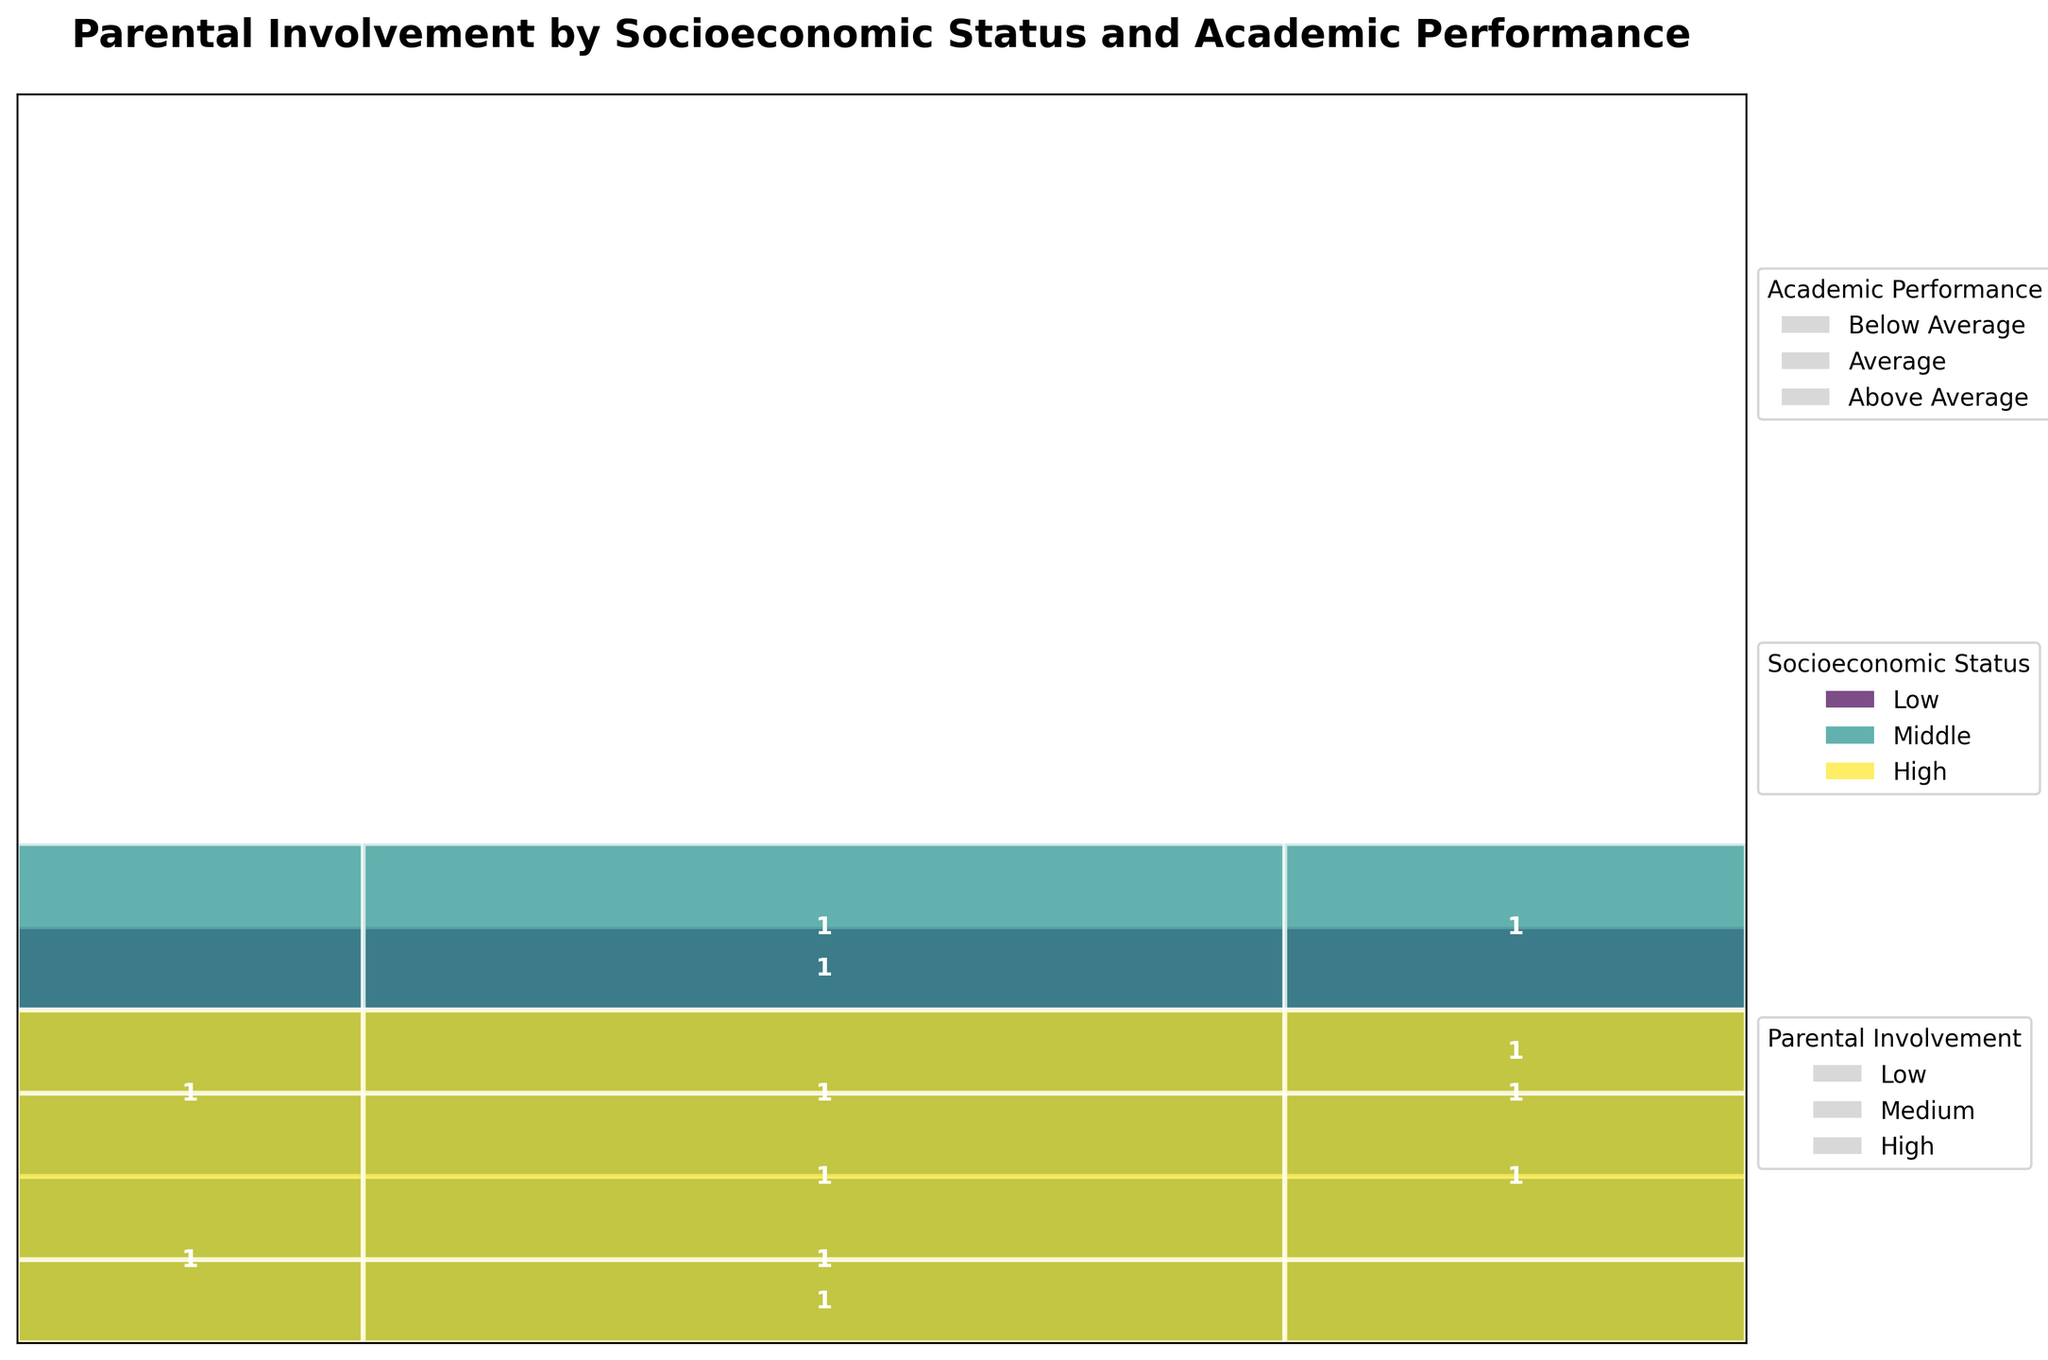What is the title of the mosaic plot? The title can be found at the top of the plot. This mosaic plot is titled "Parental Involvement by Socioeconomic Status and Academic Performance" as indicated in the code.
Answer: Parental Involvement by Socioeconomic Status and Academic Performance Which color represents the "Low" socioeconomic status? The color representing each socioeconomic status can be inferred from the plot's legend. For "Low," the plot uses the first color in the viridis color map.
Answer: The first color How many instances involve "High" socioeconomic status with "Above Average" academic performance? Examine the plot segment for "High" socioeconomic status intersecting with "Above Average" academic performance. From the text labels within the rectangles, you will see the count.
Answer: 1 Among "Middle" socioeconomic status, which academic performance category has the highest parental involvement? Look for the tallest rectangles within the "Middle" socioeconomic status' sections and check which academic performance category has the tallest bar with the highest parental involvement.
Answer: "Above Average," "High" Compare the level of parental involvement for "Low" socioeconomic status across different academic performances. What do you notice? Review the sections corresponding to "Low" socioeconomic status for each academic performance level. Identify the parental involvement levels by looking at the size of the rectangles and their counts.
Answer: Low involvement varies, with the lowest in "Below Average." Which socioeconomic status shows the most "Medium" parental involvement overall? Assess the total number of rectangles colored to depict "Medium" involvement across all socioeconomic statuses by comparing sizes of segments under "Medium" parental involvement.
Answer: Middle What is the proportion of "Average" academic performance to the total for "Middle" socioeconomic status? Sum up the counts for "Average" academic performance within "Middle" socioeconomic status and divide by the total counts for "Middle" socioeconomic status to get the proportion. Check visually or by adding labels.
Answer: Calculate sum of "Average" in "Middle," divide by the total How many instances show "Medium" parental involvement and "Below Average" academic performance for all socioeconomic statuses? Look at the sections corresponding to "Medium" parental involvement and "Below Average" academic performance for each socioeconomic status. Sum the counts from these sections.
Answer: Add the counts for all socioeconomic statuses Between "High" and "Low" socioeconomic statuses, which has more instances of "Above Average" academic performance combined with "High" parental involvement? Locate the sections for "High" parental involvement within "Above Average" academic performance for both "High" and "Low" socioeconomic statuses. Compare the counts directly.
Answer: More in "High" socioeconomic status Which socioeconomic status has the least instances of "Low" parental involvement with "Above Average" academic performance? Check the rectangles representing "Low" parental involvement intersecting with "Above Average" academic performance, and find the one with the least count.
Answer: High socioeconomic status 